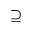Convert formula to latex. <formula><loc_0><loc_0><loc_500><loc_500>\supseteq</formula> 